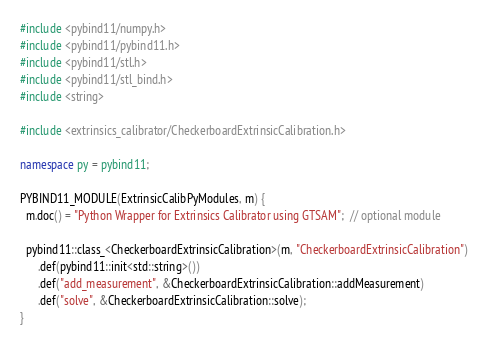Convert code to text. <code><loc_0><loc_0><loc_500><loc_500><_C++_>#include <pybind11/numpy.h>
#include <pybind11/pybind11.h>
#include <pybind11/stl.h>
#include <pybind11/stl_bind.h>
#include <string>

#include <extrinsics_calibrator/CheckerboardExtrinsicCalibration.h>

namespace py = pybind11;

PYBIND11_MODULE(ExtrinsicCalibPyModules, m) {
  m.doc() = "Python Wrapper for Extrinsics Calibrator using GTSAM";  // optional module

  pybind11::class_<CheckerboardExtrinsicCalibration>(m, "CheckerboardExtrinsicCalibration")
      .def(pybind11::init<std::string>())
      .def("add_measurement", &CheckerboardExtrinsicCalibration::addMeasurement)
      .def("solve", &CheckerboardExtrinsicCalibration::solve);
}</code> 